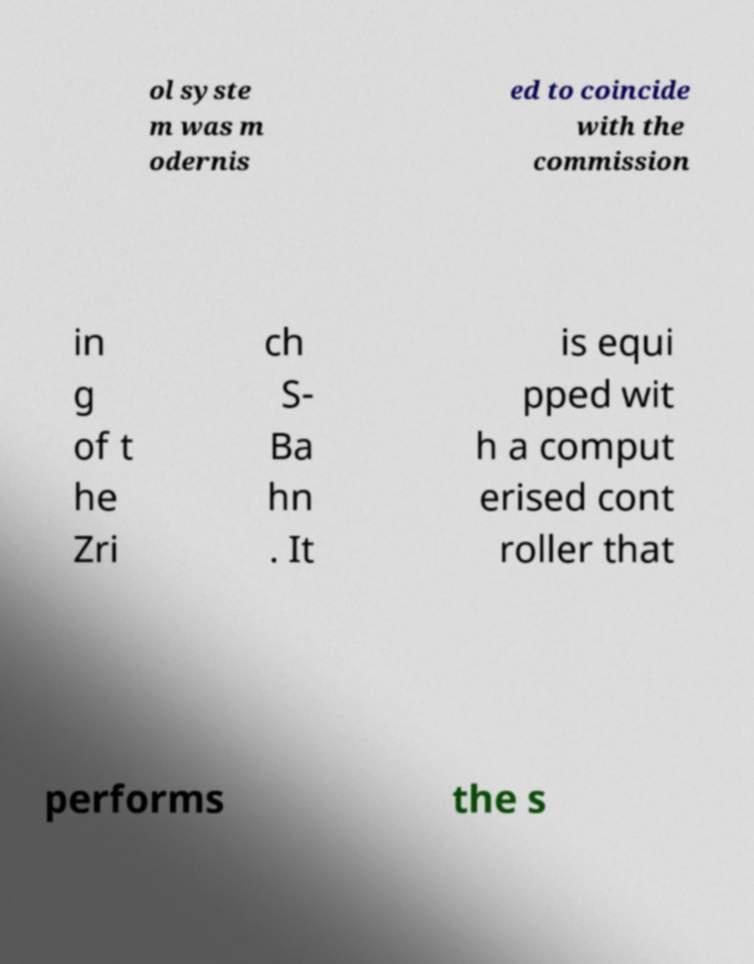There's text embedded in this image that I need extracted. Can you transcribe it verbatim? ol syste m was m odernis ed to coincide with the commission in g of t he Zri ch S- Ba hn . It is equi pped wit h a comput erised cont roller that performs the s 